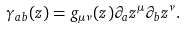<formula> <loc_0><loc_0><loc_500><loc_500>\gamma _ { a b } ( z ) = g _ { \mu \nu } ( z ) \partial _ { a } z ^ { \mu } \partial _ { b } z ^ { \nu } .</formula> 